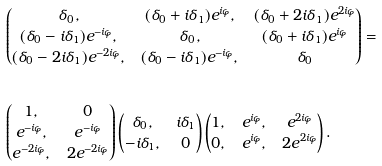<formula> <loc_0><loc_0><loc_500><loc_500>\ & \begin{pmatrix} \delta { _ { 0 } } , & ( \delta _ { 0 } + i \delta { _ { 1 } } ) e ^ { i \varphi } , & ( \delta _ { 0 } + 2 i \delta { _ { 1 } } ) e ^ { 2 i \varphi } \\ ( \delta _ { 0 } - i \delta { _ { 1 } } ) e ^ { - i \varphi } , & \delta { _ { 0 } } , & ( \delta _ { 0 } + i \delta { _ { 1 } } ) e ^ { i \varphi } \\ ( \delta _ { 0 } - 2 i \delta { _ { 1 } } ) e ^ { - 2 i \varphi } , & ( \delta _ { 0 } - i \delta { _ { 1 } } ) e ^ { - i \varphi } , & \delta _ { 0 } \end{pmatrix} = \\ \ & \quad \\ \ & \begin{pmatrix} 1 , & 0 \\ e ^ { - i \varphi } , & e ^ { - i \varphi } \\ e ^ { - 2 i \varphi } , & 2 e ^ { - 2 i \varphi } \\ \end{pmatrix} \begin{pmatrix} \delta _ { 0 } , & i \delta _ { 1 } \\ - i \delta _ { 1 } , & 0 \end{pmatrix} \begin{pmatrix} 1 , & e ^ { i \varphi } , & e ^ { 2 i \varphi } \\ 0 , & e ^ { i \varphi } , & 2 e ^ { 2 i \varphi } \end{pmatrix} .</formula> 